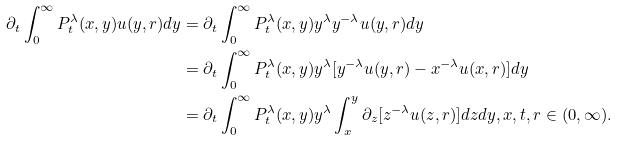Convert formula to latex. <formula><loc_0><loc_0><loc_500><loc_500>\partial _ { t } \int _ { 0 } ^ { \infty } P _ { t } ^ { \lambda } ( x , y ) u ( y , r ) d y & = \partial _ { t } \int _ { 0 } ^ { \infty } P _ { t } ^ { \lambda } ( x , y ) y ^ { \lambda } y ^ { - \lambda } u ( y , r ) d y \\ & = \partial _ { t } \int _ { 0 } ^ { \infty } P _ { t } ^ { \lambda } ( x , y ) y ^ { \lambda } [ y ^ { - \lambda } u ( y , r ) - x ^ { - \lambda } u ( x , r ) ] d y \\ & = \partial _ { t } \int _ { 0 } ^ { \infty } P _ { t } ^ { \lambda } ( x , y ) y ^ { \lambda } \int _ { x } ^ { y } \partial _ { z } [ z ^ { - \lambda } u ( z , r ) ] d z d y , x , t , r \in ( 0 , \infty ) .</formula> 